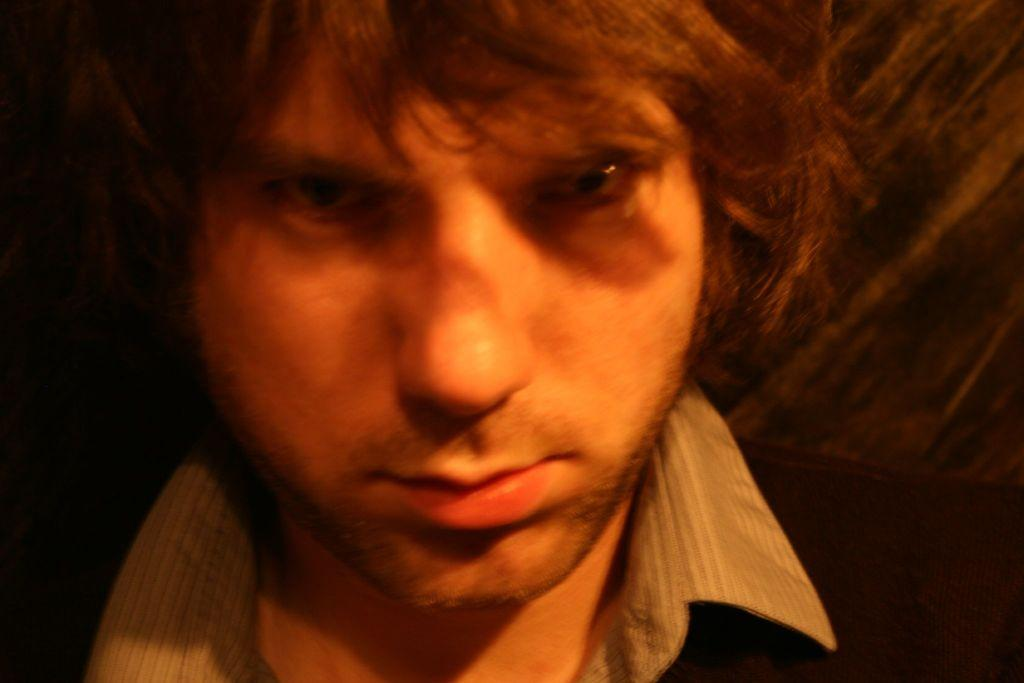What is present in the image? There is a person in the image. Can you describe the person? The person is a man. What part of the man's face is visible in the image? Only the face of the man is visible in the image. What facial features can be seen on the man? The man has eyes, a nose, and a mouth. Does the man have hair? Yes, the man has hair. What type of teeth can be seen in the man's mouth in the image? The image only shows the man's face, and his mouth is not open, so his teeth are not visible. 